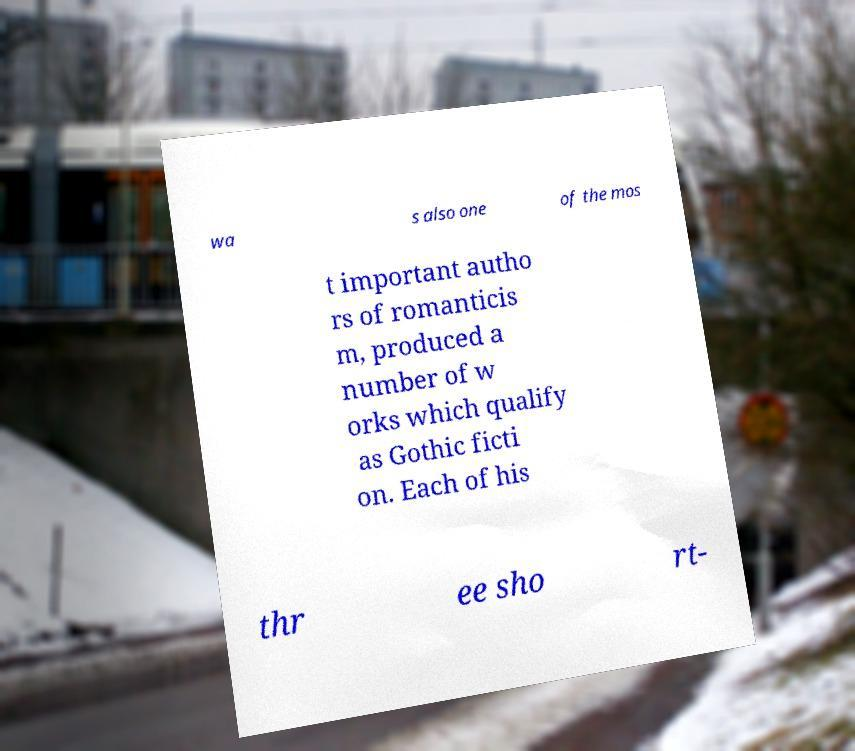Could you extract and type out the text from this image? wa s also one of the mos t important autho rs of romanticis m, produced a number of w orks which qualify as Gothic ficti on. Each of his thr ee sho rt- 